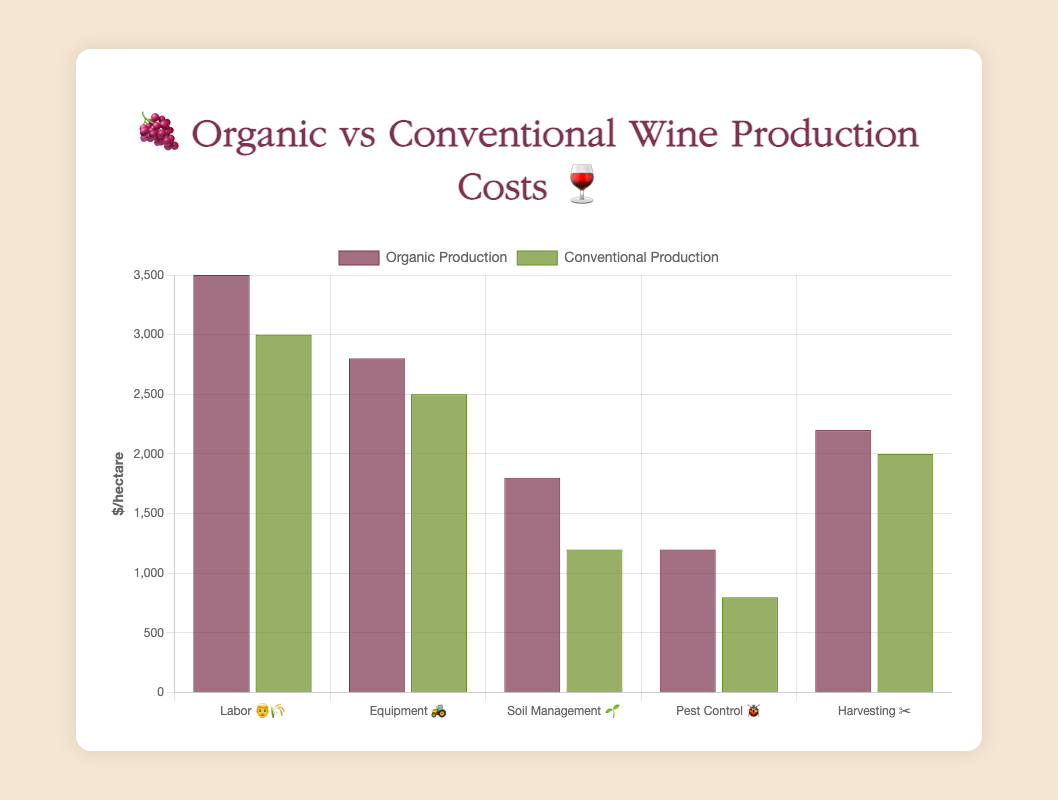What is the title of the chart? The title of the chart is positioned at the top and gives an overview of the content. In this chart, the title is "🍇 Organic vs Conventional Wine Production Costs 🍷".
Answer: 🍇 Organic vs Conventional Wine Production Costs 🍷 Which category has the highest cost in organic wine production? Look at the organic production bar heights. The bar labeled "Labor 👨‍🌾" is the tallest, indicating the highest cost.
Answer: Labor 👨‍🌾 Which category costs more in organic production than in conventional production by the largest margin? Calculate the differences for each category: Labor (3500-3000 = 500), Equipment (2800-2500 = 300), Soil Management (1800-1200 = 600), Pest Control (1200-800 = 400), Harvesting (2200-2000 = 200). Soil Management has the largest difference of 600.
Answer: Soil Management 🌱 What is the total cost for conventional production across all categories? Sum the conventional production costs: 3000 + 2500 + 1200 + 800 + 2000. Total is 9500.
Answer: $9500 How much more does pest control cost for organic production compared to conventional production? Subtract conventional cost for pest control from the organic cost: 1200 - 800 = 400.
Answer: $400 Which category has the smallest cost in both organic and conventional production? Identify the smallest bar for both organic and conventional production. For both, "Pest Control 🐞" (🍷) has the smallest cost.
Answer: Pest Control 🐞 / 🧴 What is the difference in cost between organic and conventional production for harvesting? Subtract the conventional cost from the organic cost for Harvesting: 2200 - 2000 = 200.
Answer: $200 Which cost is greater for organic production: Equipment or Soil Management? Compare the heights of the bars labeled "Equipment 🚜" and "Soil Management 🌱". Equipment costs are higher (2800 vs. 1800).
Answer: Equipment 🚜 What is the average cost of organic production across all categories? Sum the costs for organic production and divide by the number of categories: (3500 + 2800 + 1800 + 1200 + 2200)/5 = 2500.
Answer: $2500/unit 